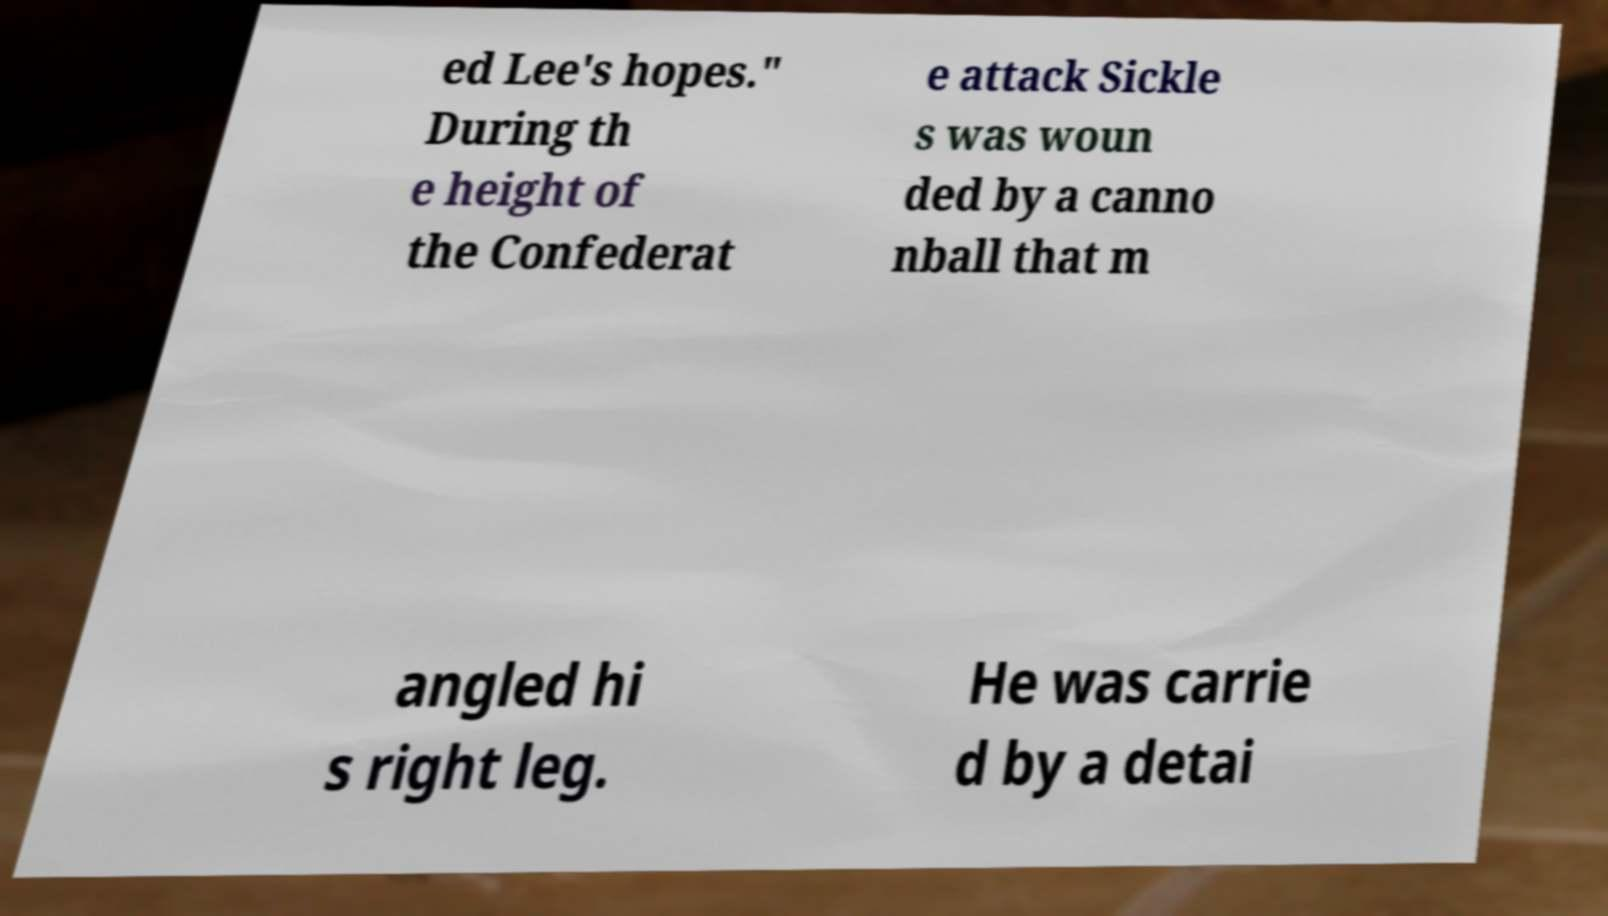Can you read and provide the text displayed in the image?This photo seems to have some interesting text. Can you extract and type it out for me? ed Lee's hopes." During th e height of the Confederat e attack Sickle s was woun ded by a canno nball that m angled hi s right leg. He was carrie d by a detai 